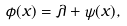<formula> <loc_0><loc_0><loc_500><loc_500>\phi ( x ) = \lambda + \psi ( x ) ,</formula> 